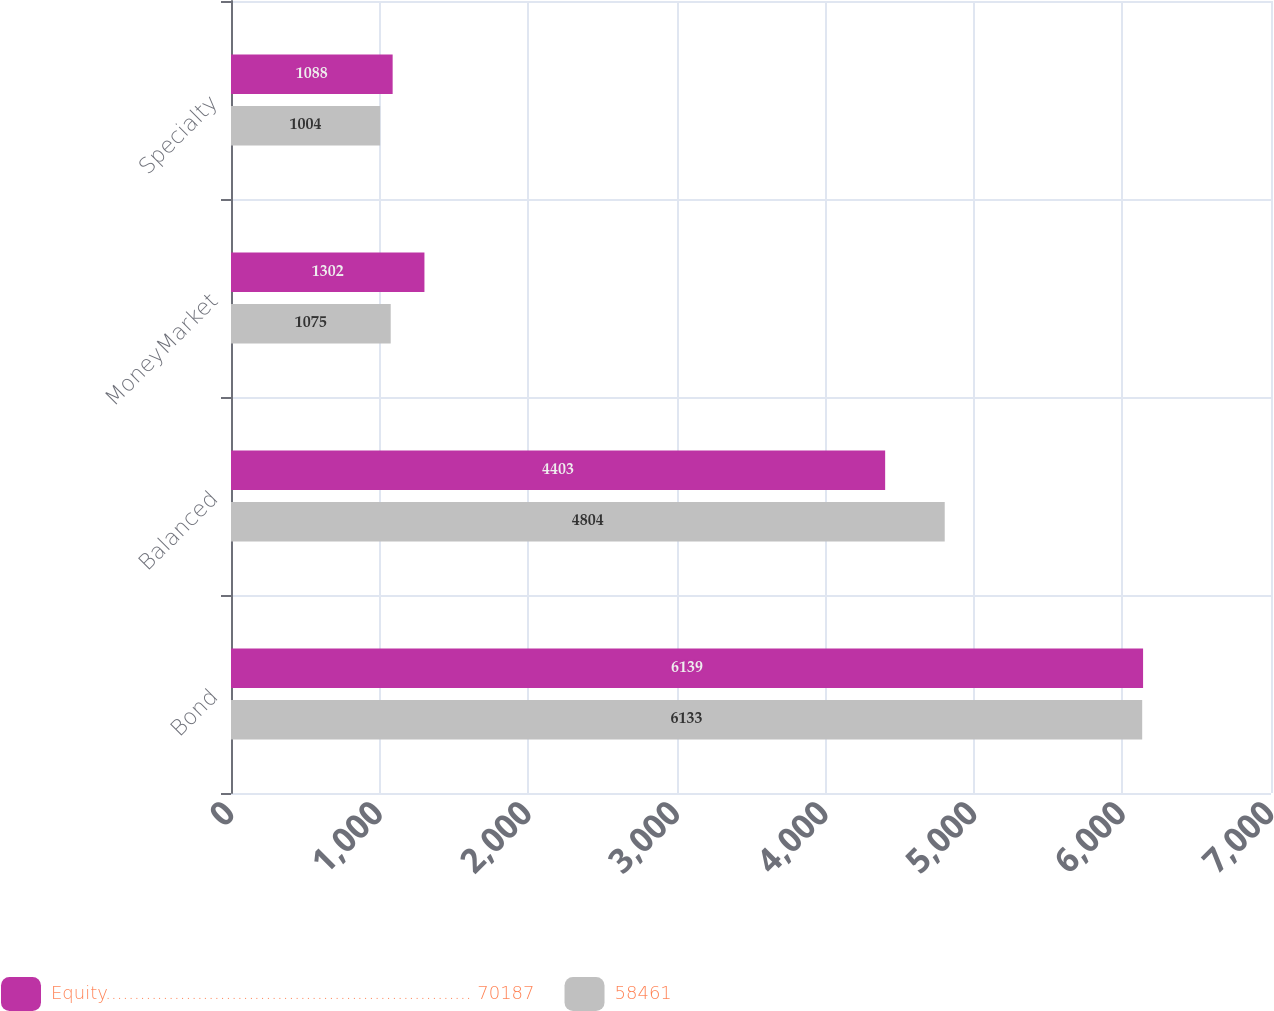Convert chart. <chart><loc_0><loc_0><loc_500><loc_500><stacked_bar_chart><ecel><fcel>Bond<fcel>Balanced<fcel>MoneyMarket<fcel>Specialty<nl><fcel>Equity................................................................ 70187<fcel>6139<fcel>4403<fcel>1302<fcel>1088<nl><fcel>58461<fcel>6133<fcel>4804<fcel>1075<fcel>1004<nl></chart> 